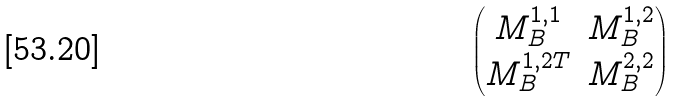<formula> <loc_0><loc_0><loc_500><loc_500>\begin{pmatrix} M _ { B } ^ { 1 , 1 } & M _ { B } ^ { 1 , 2 } \\ M _ { B } ^ { 1 , 2 T } & M _ { B } ^ { 2 , 2 } \end{pmatrix}</formula> 